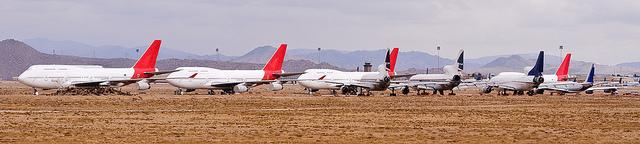What is the main factor keeping the planes on the dirt?

Choices:
A) aerodynamics
B) age
C) production
D) gas age 